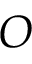Convert formula to latex. <formula><loc_0><loc_0><loc_500><loc_500>O</formula> 